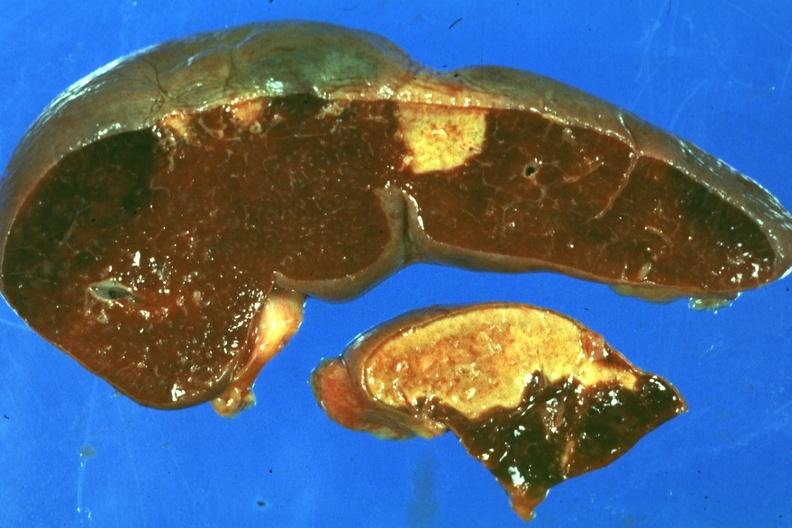s infarct present?
Answer the question using a single word or phrase. Yes 